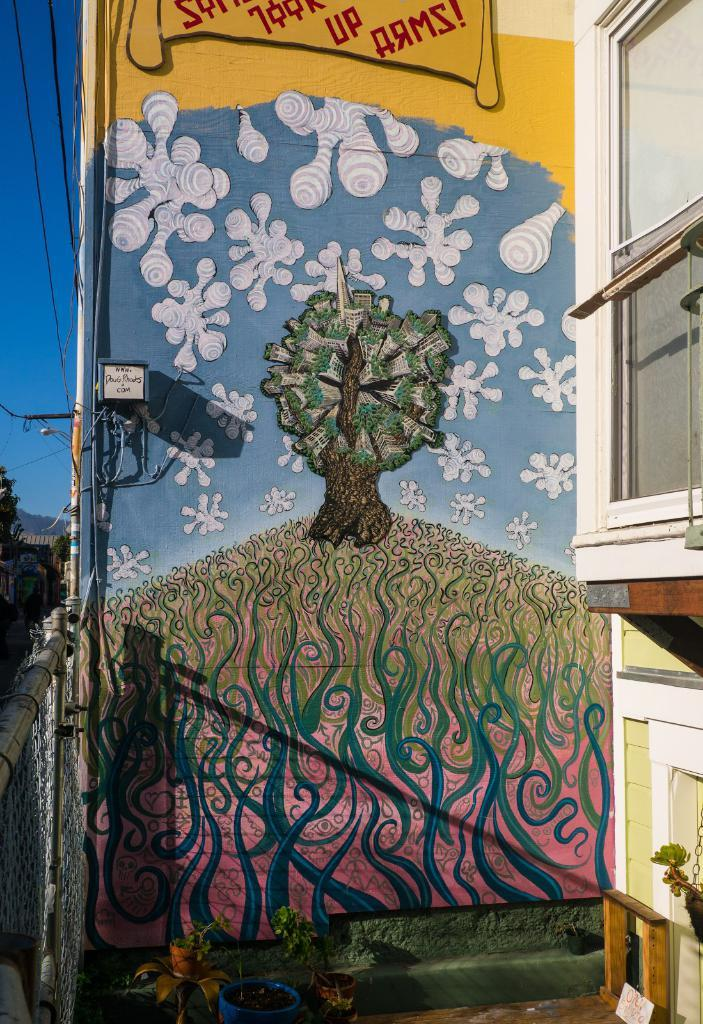What is depicted in the painting in the image? There is a painting of a tree in the image. What type of structure can be seen on the left side of the image? There is a building on the left side of the image. What is located on the right side of the image? There is a fence on the right side of the image. Where is the pump located in the image? There is no pump present in the image. What type of gate can be seen in the image? There is no gate present in the image. 